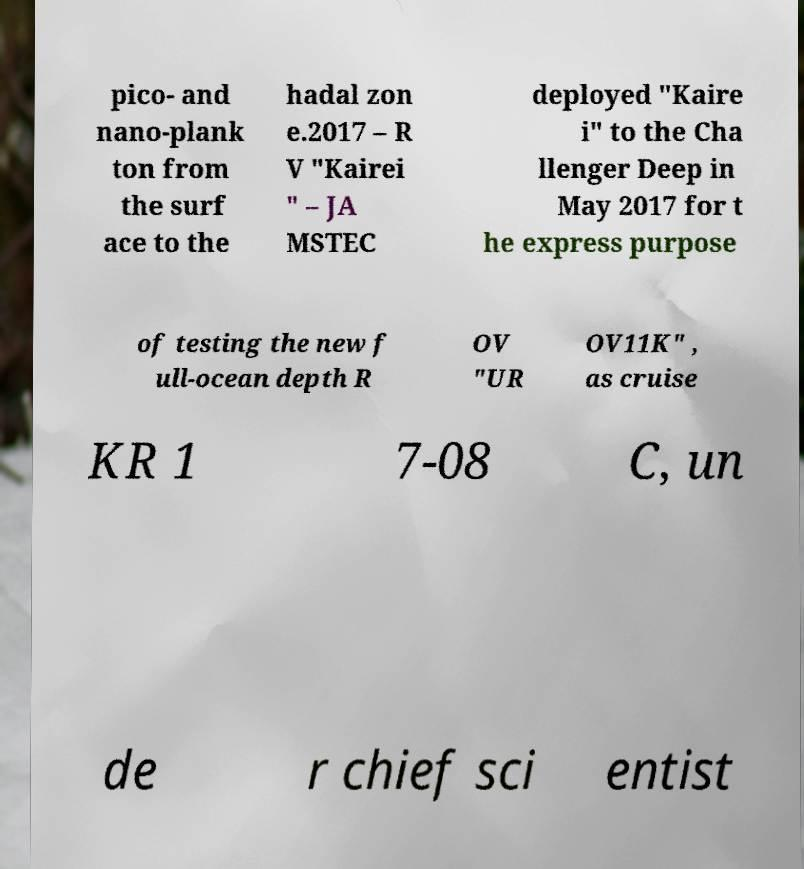Please read and relay the text visible in this image. What does it say? pico- and nano-plank ton from the surf ace to the hadal zon e.2017 – R V "Kairei " – JA MSTEC deployed "Kaire i" to the Cha llenger Deep in May 2017 for t he express purpose of testing the new f ull-ocean depth R OV "UR OV11K" , as cruise KR 1 7-08 C, un de r chief sci entist 